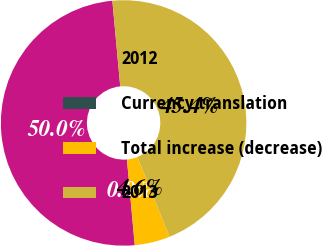Convert chart. <chart><loc_0><loc_0><loc_500><loc_500><pie_chart><fcel>2012<fcel>Currency translation<fcel>Total increase (decrease)<fcel>2013<nl><fcel>49.97%<fcel>0.03%<fcel>4.64%<fcel>45.36%<nl></chart> 